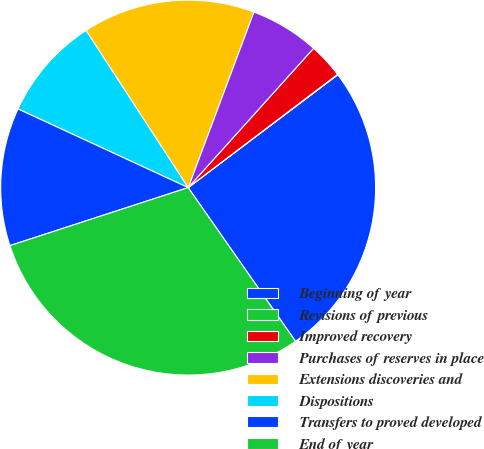Convert chart to OTSL. <chart><loc_0><loc_0><loc_500><loc_500><pie_chart><fcel>Beginning of year<fcel>Revisions of previous<fcel>Improved recovery<fcel>Purchases of reserves in place<fcel>Extensions discoveries and<fcel>Dispositions<fcel>Transfers to proved developed<fcel>End of year<nl><fcel>25.58%<fcel>0.04%<fcel>3.01%<fcel>5.97%<fcel>14.87%<fcel>8.94%<fcel>11.9%<fcel>29.7%<nl></chart> 